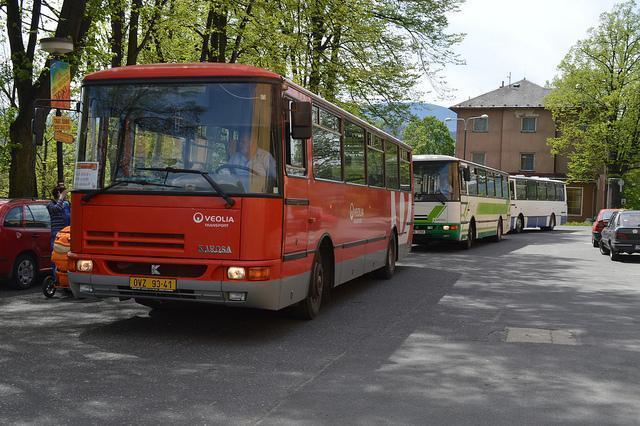How many busses are shown?
Give a very brief answer. 3. How many buses are in the photo?
Give a very brief answer. 3. 